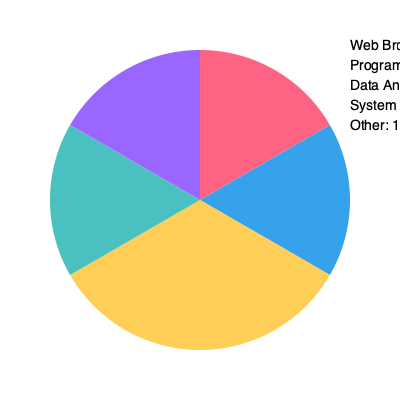Based on the pie chart showing computer usage statistics, what percentage of time is spent on activities directly related to software development (programming and system administration combined)? To answer this question, we need to follow these steps:

1. Identify the activities directly related to software development:
   - Programming: 25%
   - System Administration: 15%

2. Add the percentages of these activities:
   $25\% + 15\% = 40\%$

3. Verify that this makes sense in the context of the pie chart:
   - We can see that the combined slices for programming (blue) and system administration (teal) indeed make up a significant portion of the chart, consistent with our calculation.

4. Consider the relevance to the persona:
   As a computer scientist who taught full-stack development and system administration, this question highlights the importance of these core activities in computer usage.
Answer: 40% 